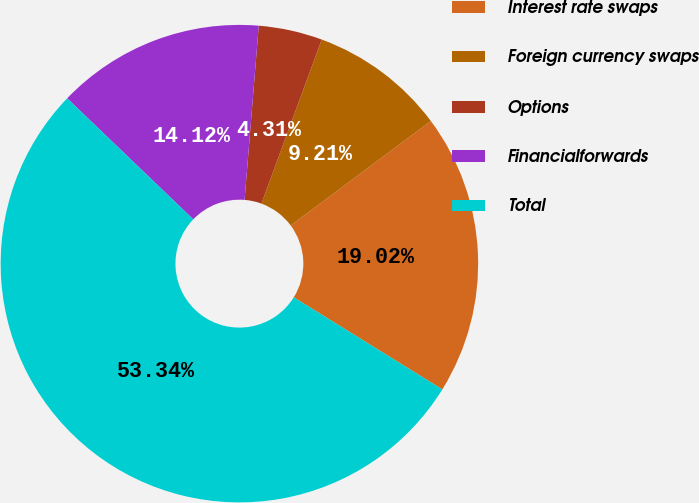Convert chart to OTSL. <chart><loc_0><loc_0><loc_500><loc_500><pie_chart><fcel>Interest rate swaps<fcel>Foreign currency swaps<fcel>Options<fcel>Financialforwards<fcel>Total<nl><fcel>19.02%<fcel>9.21%<fcel>4.31%<fcel>14.12%<fcel>53.34%<nl></chart> 